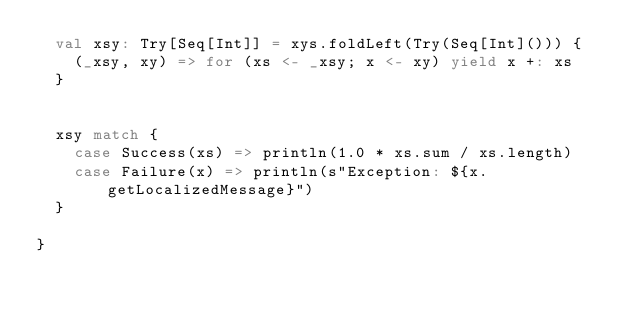<code> <loc_0><loc_0><loc_500><loc_500><_Scala_>  val xsy: Try[Seq[Int]] = xys.foldLeft(Try(Seq[Int]())) {
    (_xsy, xy) => for (xs <- _xsy; x <- xy) yield x +: xs
  }


  xsy match {
    case Success(xs) => println(1.0 * xs.sum / xs.length)
    case Failure(x) => println(s"Exception: ${x.getLocalizedMessage}")
  }

}
</code> 